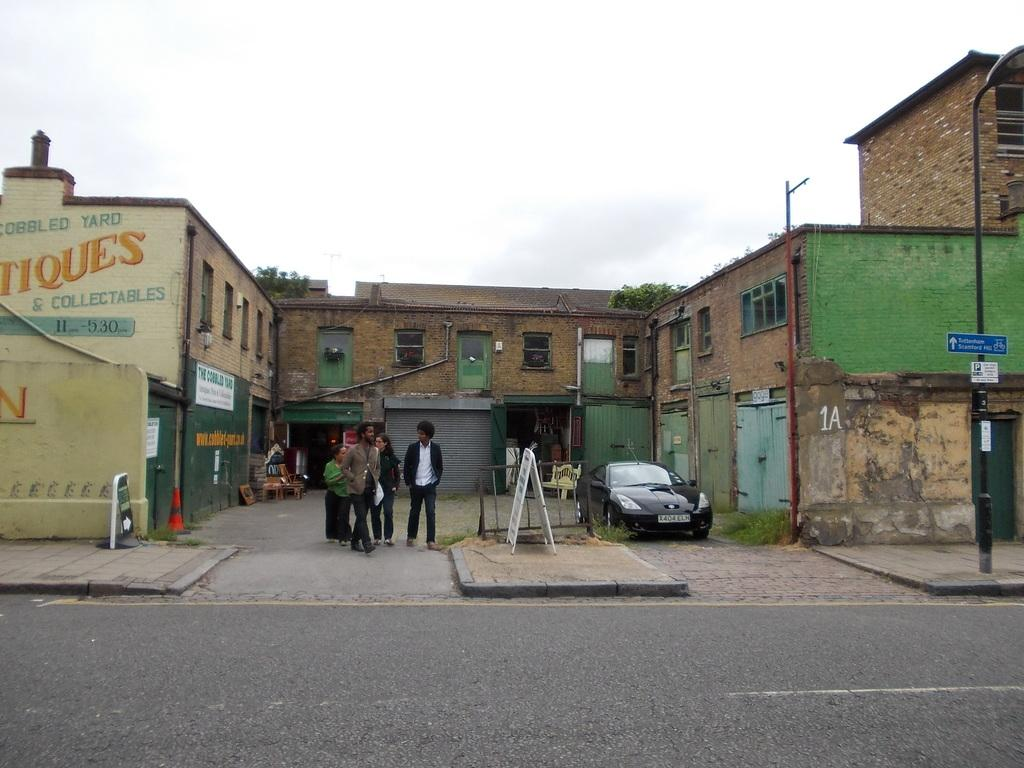What type of structures can be seen in the image? There are buildings in the image. What other natural elements are present in the image? There are trees in the image. What man-made objects can be seen in the image? There are boards and stands in the image. What mode of transportation is visible in the image? There is a vehicle in the image. What else can be found in the image? There are objects and people in the image. What part of the natural environment is visible in the image? The sky is visible at the top of the image. What part of the man-made environment is visible in the image? There is a road visible at the bottom of the image. Can you tell me how many times the people in the image sneeze? There is no indication in the image that anyone is sneezing, so it cannot be determined from the picture. What type of space object can be seen in the image? There is no space object present in the image; it features buildings, trees, boards, stands, a vehicle, objects, and people. 